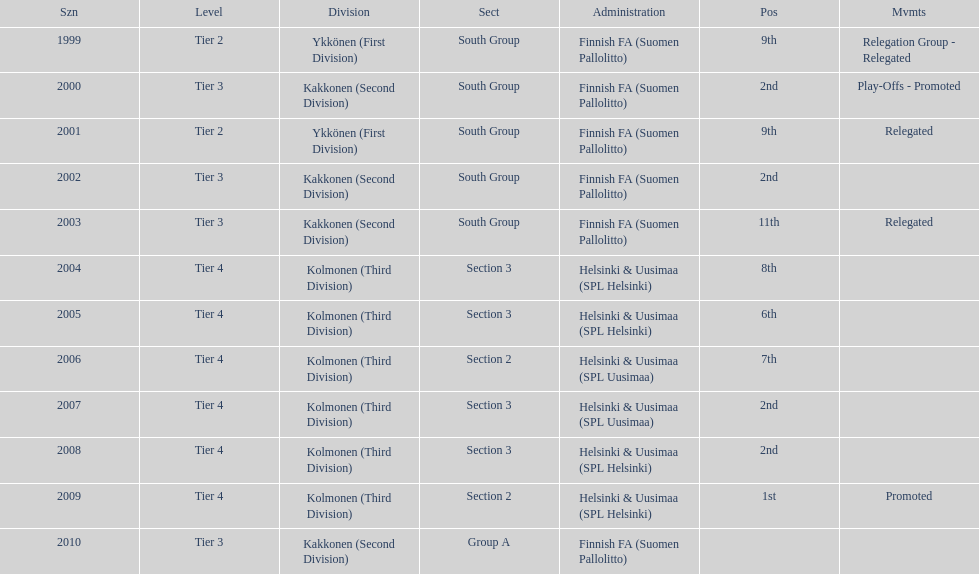How many consecutive times did they play in tier 4? 6. 